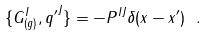<formula> <loc_0><loc_0><loc_500><loc_500>\{ G ^ { I } _ { ( g ) } , { q ^ { \prime } } ^ { J } \} = - P ^ { I J } \delta ( x - x ^ { \prime } ) \ .</formula> 